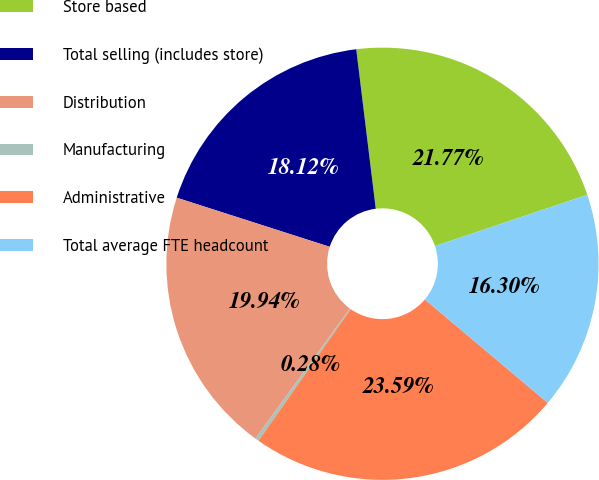Convert chart to OTSL. <chart><loc_0><loc_0><loc_500><loc_500><pie_chart><fcel>Store based<fcel>Total selling (includes store)<fcel>Distribution<fcel>Manufacturing<fcel>Administrative<fcel>Total average FTE headcount<nl><fcel>21.77%<fcel>18.12%<fcel>19.94%<fcel>0.28%<fcel>23.59%<fcel>16.3%<nl></chart> 